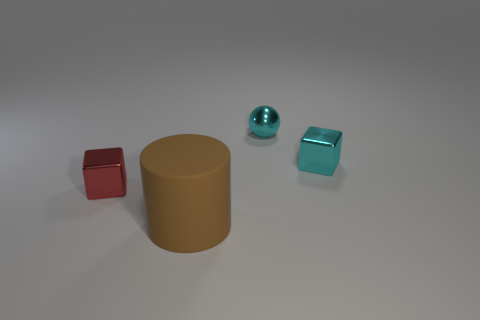Subtract all red blocks. How many blocks are left? 1 Add 2 red shiny objects. How many objects exist? 6 Subtract all cylinders. How many objects are left? 3 Subtract 1 balls. How many balls are left? 0 Subtract all purple spheres. How many cyan blocks are left? 1 Add 2 rubber objects. How many rubber objects exist? 3 Subtract 0 green cubes. How many objects are left? 4 Subtract all purple balls. Subtract all gray cylinders. How many balls are left? 1 Subtract all shiny things. Subtract all large brown cylinders. How many objects are left? 0 Add 3 rubber things. How many rubber things are left? 4 